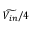Convert formula to latex. <formula><loc_0><loc_0><loc_500><loc_500>\widetilde { V _ { i n } } / 4</formula> 